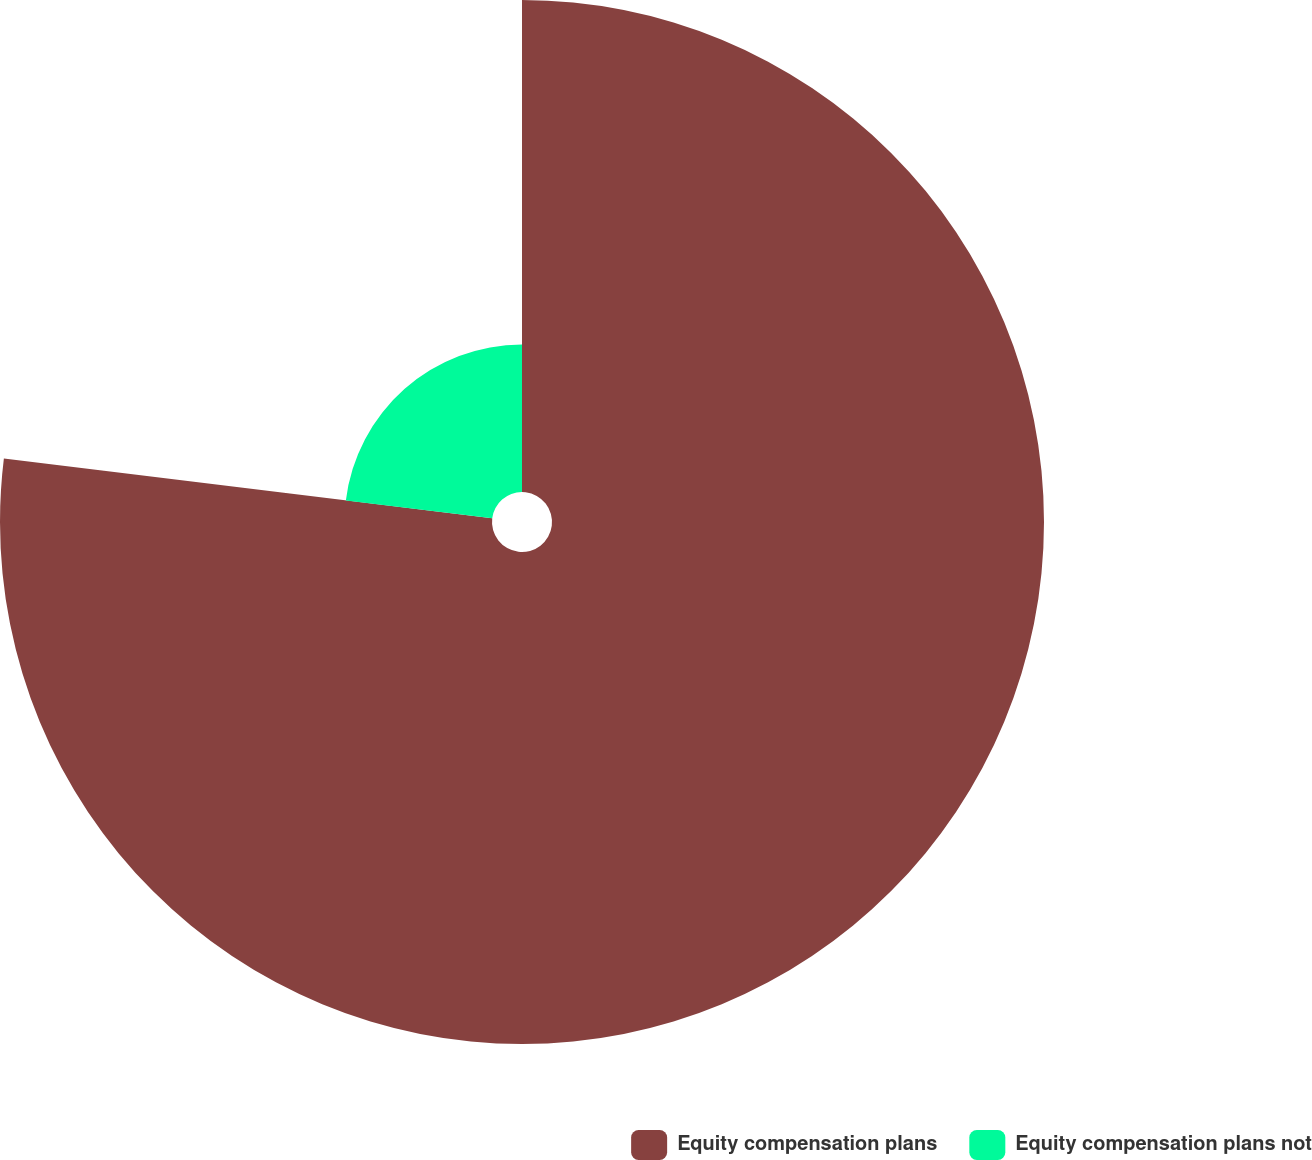Convert chart. <chart><loc_0><loc_0><loc_500><loc_500><pie_chart><fcel>Equity compensation plans<fcel>Equity compensation plans not<nl><fcel>76.94%<fcel>23.06%<nl></chart> 